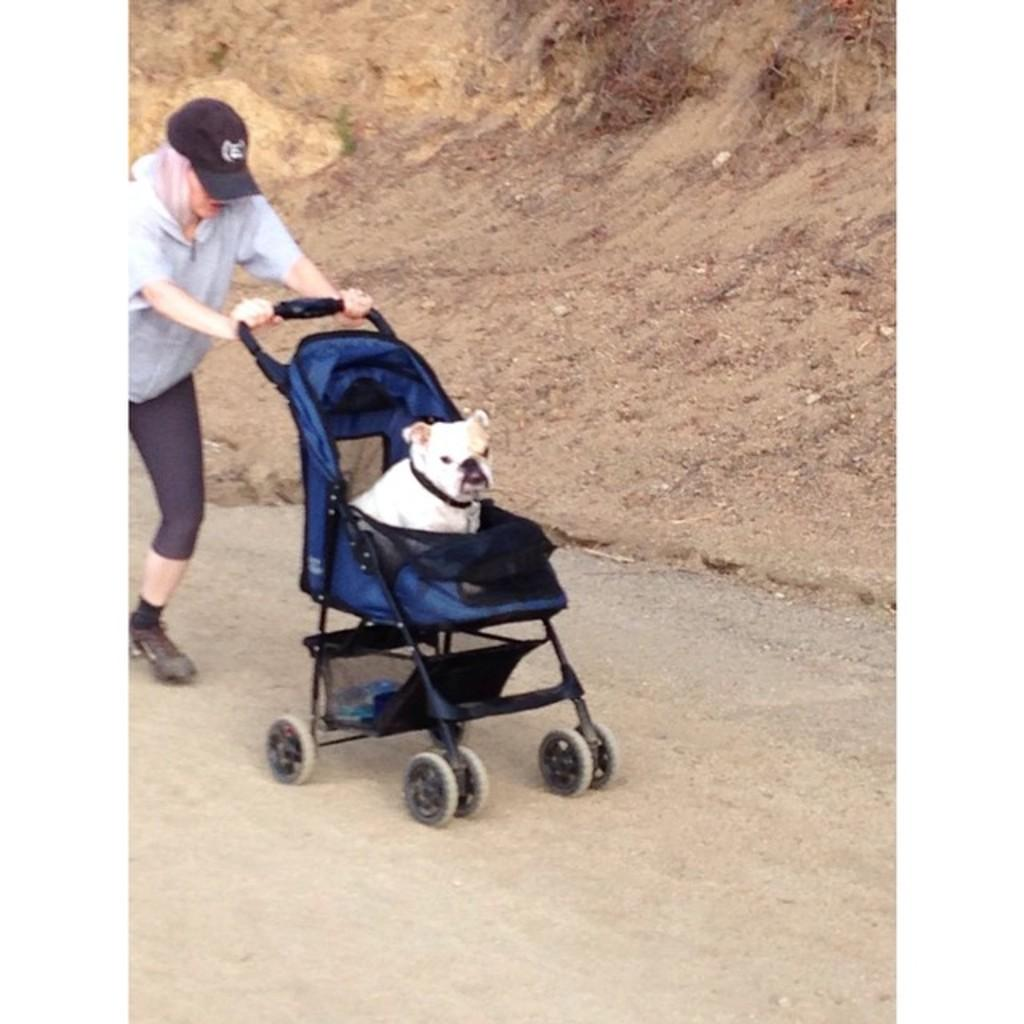What is the person in the image doing? The person is walking in the image. What is the person holding while walking? The person is holding a baby traveler. What can be seen on the baby traveler? A dog is sitting on the dog is sitting on the baby traveler. What is visible at the back of the image? There is mud at the back of the image. What is at the bottom of the image? There is a road at the bottom of the image. How many jars of pickles are visible in the image? There are no jars of pickles present in the image. What type of giants can be seen in the image? There are no giants present in the image. 